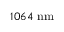Convert formula to latex. <formula><loc_0><loc_0><loc_500><loc_500>1 0 6 4 n m</formula> 